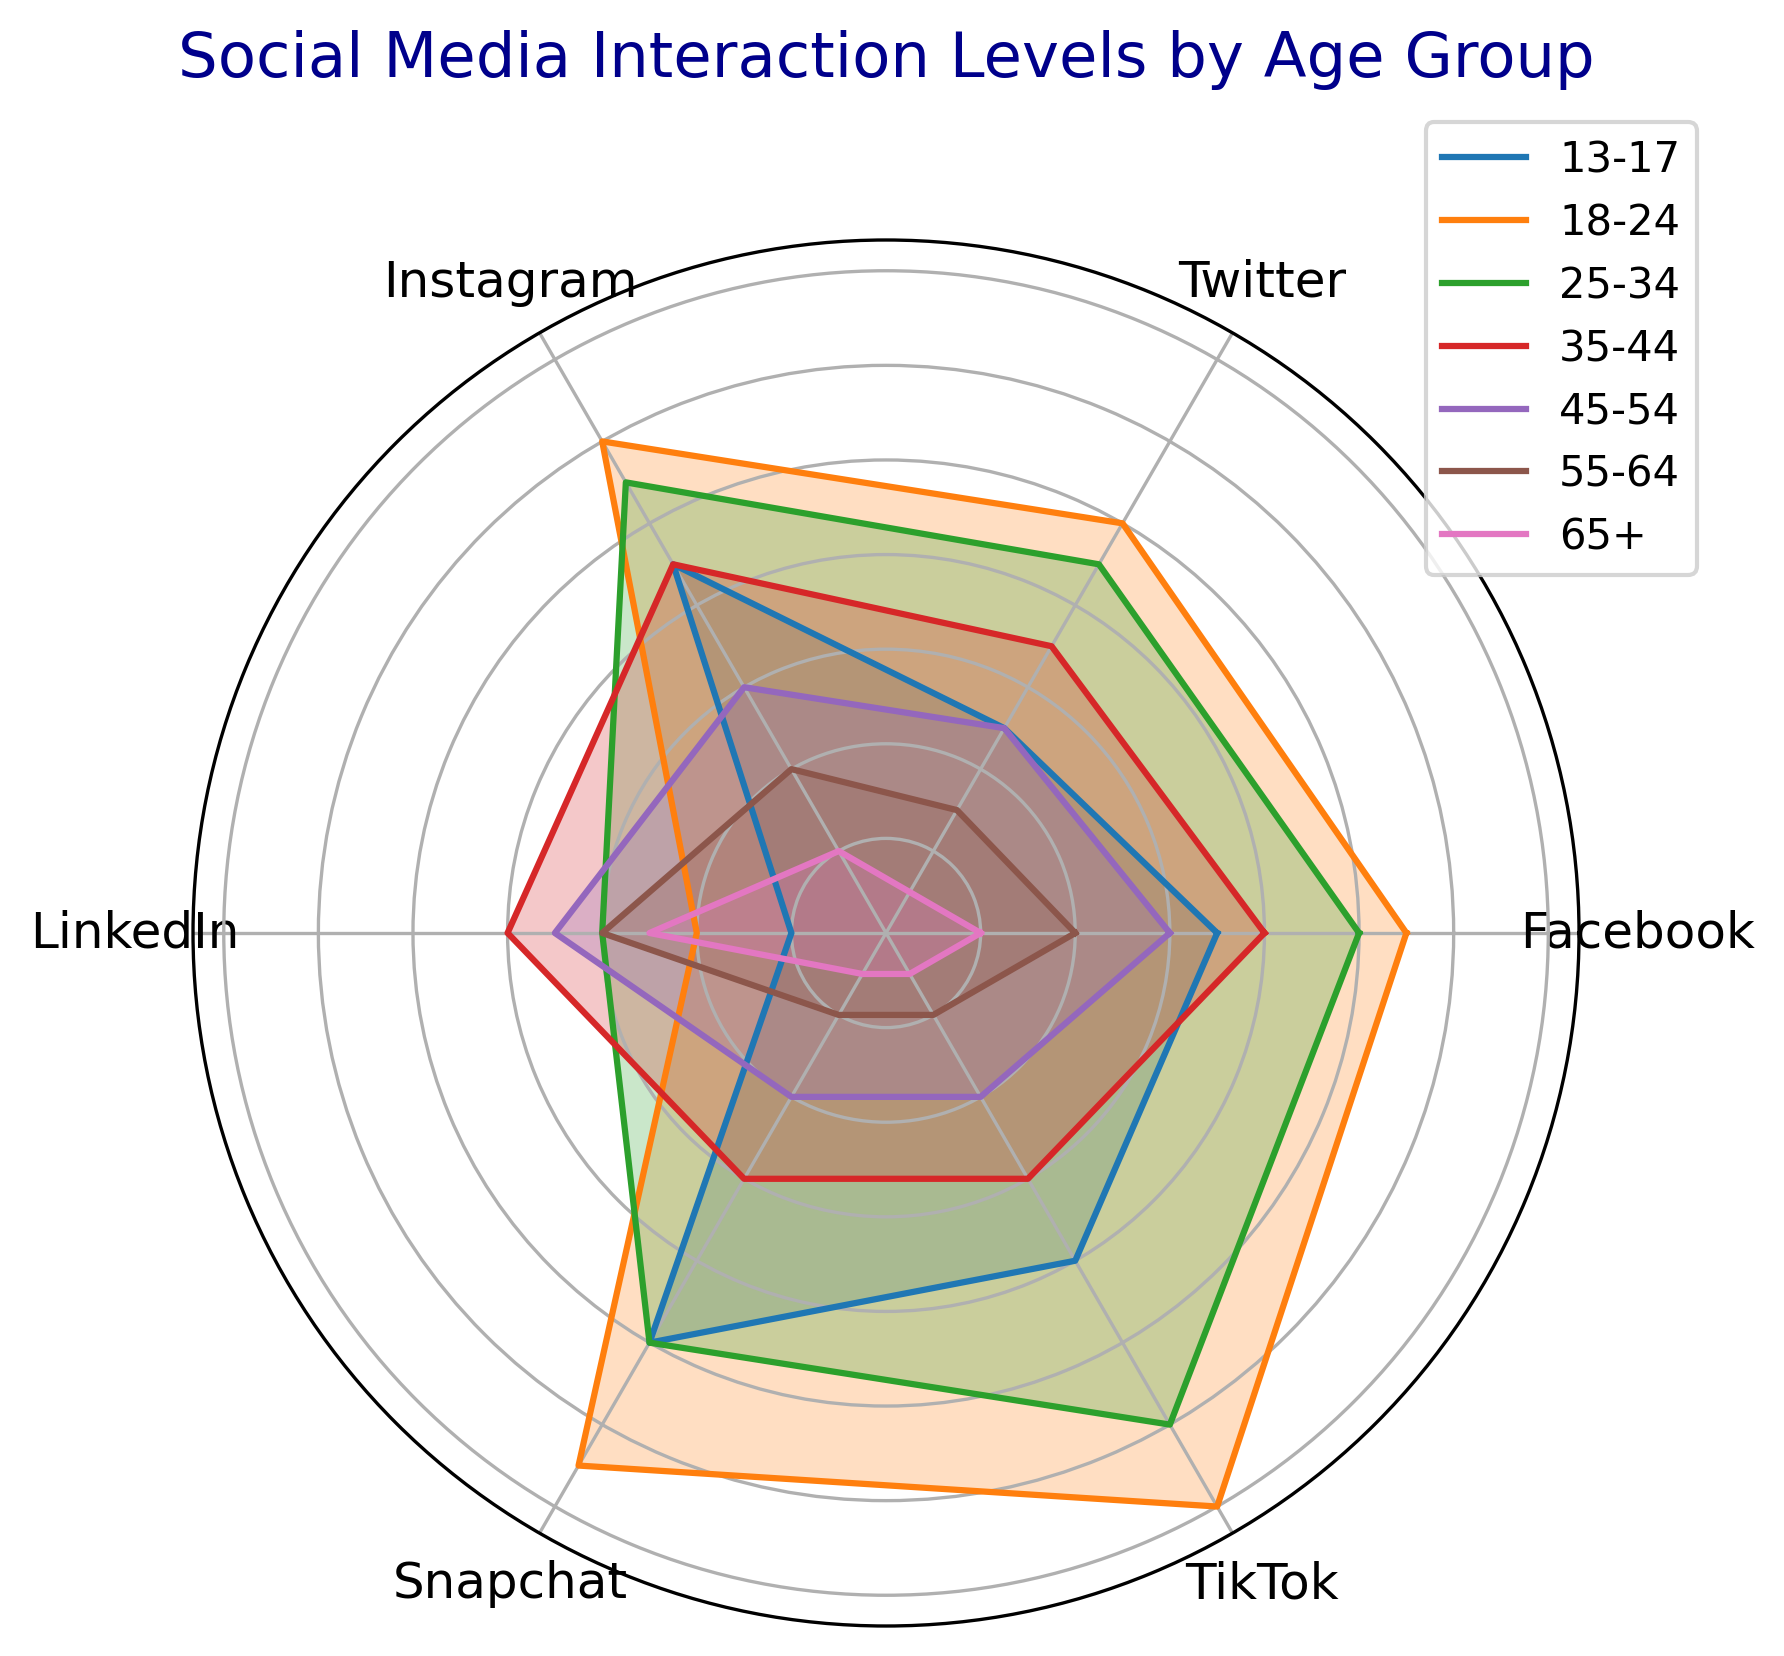What age group has the highest interaction on Instagram? Looking at the plot, the age group with the highest interaction level on Instagram is the one with the longest segment for Instagram. The longest segment for Instagram corresponds to the 18-24 age group.
Answer: 18-24 Which social media platform has the least interaction level for the 65+ age group? By inspecting the 65+ age group's segments on the plot, the shortest segment indicates the least interaction level. The shortest one is for Twitter.
Answer: Twitter What's the average interaction level across all platforms for the 35-44 age group? The interaction levels for the 35-44 age group are 40 (Facebook), 35 (Twitter), 45 (Instagram), 40 (LinkedIn), 30 (Snapchat), and 30 (TikTok). Summing these values gives 220. Dividing by the number of platforms (6) results in an average of 36.67.
Answer: 36.67 How does the interaction level for LinkedIn compare between the 25-34 and 45-54 age groups? The interaction level with LinkedIn can be compared by looking at the lengths of their segments for LinkedIn. The 25-34 age group has a level of 30, and the 45-54 age group has a level of 35, meaning the 45-54 age group interacts more with LinkedIn than the 25-34 age group.
Answer: 45-54 age group interacts more Which age group shows equal interaction levels for any two social media platforms? By checking the lengths of the segments, the 35-44 age group shows equal interaction levels for LinkedIn and TikTok, both at 40.
Answer: 35-44 For the age group of 18-24, which platform's interaction level is closer to LinkedIn than Snapchat? First, identify the interaction levels for 18-24: LinkedIn (20), Snapchat (65). Checking other platforms' levels: Facebook (55), Twitter (50), Instagram (60), TikTok (70) reveals that Facebook's level (55) is closer to LinkedIn's 20 than Snapchat's 65.
Answer: Facebook What is the difference in Snapchat interaction levels between the youngest and oldest age groups? The Snapchat interaction level for the 13-17 age group is 50, and for the 65+ age group is 5. The difference is 50 - 5.
Answer: 45 Which platform shows the most variance in interaction levels across all age groups? The variance can be visually assessed by observing which segments have the most variation across age groups. TikTok segments vary widely across the age groups from as low as 5 to as high as 70.
Answer: TikTok 